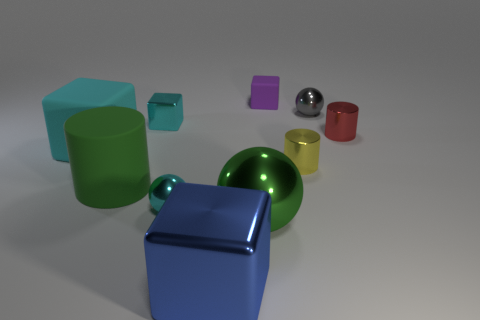Which object is the largest? The blue cube appears to be the largest object within the image. 